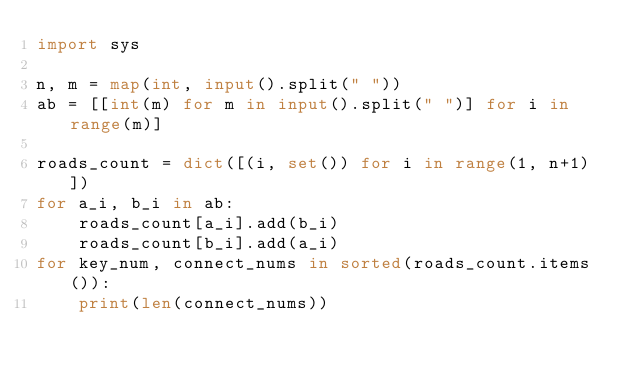<code> <loc_0><loc_0><loc_500><loc_500><_Python_>import sys

n, m = map(int, input().split(" "))
ab = [[int(m) for m in input().split(" ")] for i in range(m)]

roads_count = dict([(i, set()) for i in range(1, n+1)])
for a_i, b_i in ab:
    roads_count[a_i].add(b_i)
    roads_count[b_i].add(a_i)
for key_num, connect_nums in sorted(roads_count.items()):
    print(len(connect_nums))
</code> 